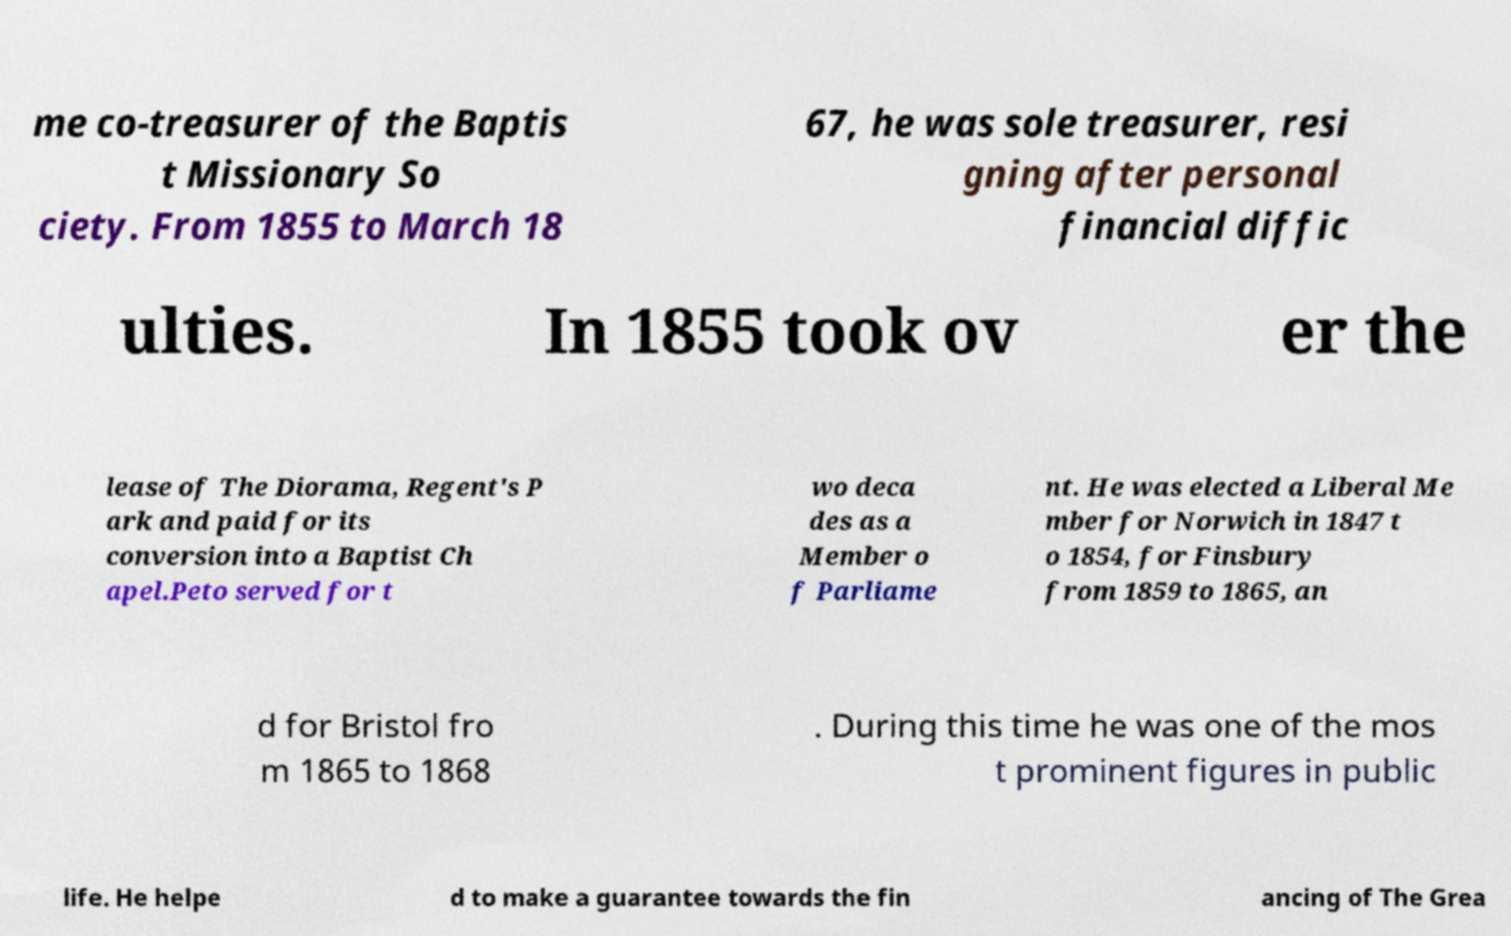For documentation purposes, I need the text within this image transcribed. Could you provide that? me co-treasurer of the Baptis t Missionary So ciety. From 1855 to March 18 67, he was sole treasurer, resi gning after personal financial diffic ulties. In 1855 took ov er the lease of The Diorama, Regent's P ark and paid for its conversion into a Baptist Ch apel.Peto served for t wo deca des as a Member o f Parliame nt. He was elected a Liberal Me mber for Norwich in 1847 t o 1854, for Finsbury from 1859 to 1865, an d for Bristol fro m 1865 to 1868 . During this time he was one of the mos t prominent figures in public life. He helpe d to make a guarantee towards the fin ancing of The Grea 